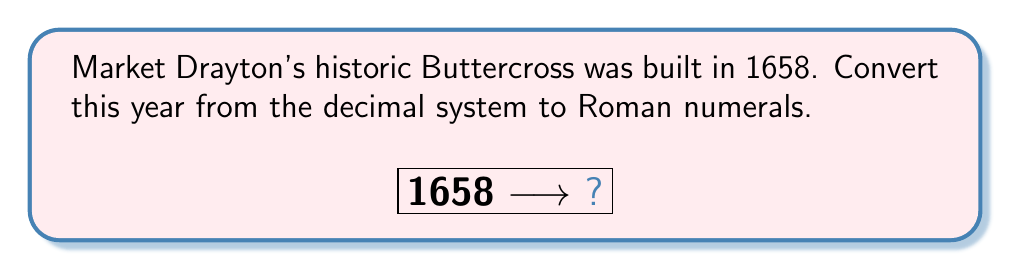Solve this math problem. To convert the year 1658 from decimal to Roman numerals, we need to break down the number and use the appropriate Roman numeral symbols. Let's proceed step-by-step:

1) First, let's recall the basic Roman numeral symbols:
   I = 1, V = 5, X = 10, L = 50, C = 100, D = 500, M = 1000

2) Now, let's break down 1658:
   1000 + 600 + 50 + 8

3) Convert each part:
   1000 = M
   600 = DC (500 + 100)
   50 = L
   8 = VIII

4) Combine the parts:
   MDCLVIII

Therefore, the year 1658 in Roman numerals is MDCLVIII.

To verify, we can break it down:
$$\text{MDCLVIII} = \text{M} + \text{D} + \text{C} + \text{L} + \text{V} + \text{III} = 1000 + 500 + 100 + 50 + 5 + 3 = 1658$$
Answer: MDCLVIII 